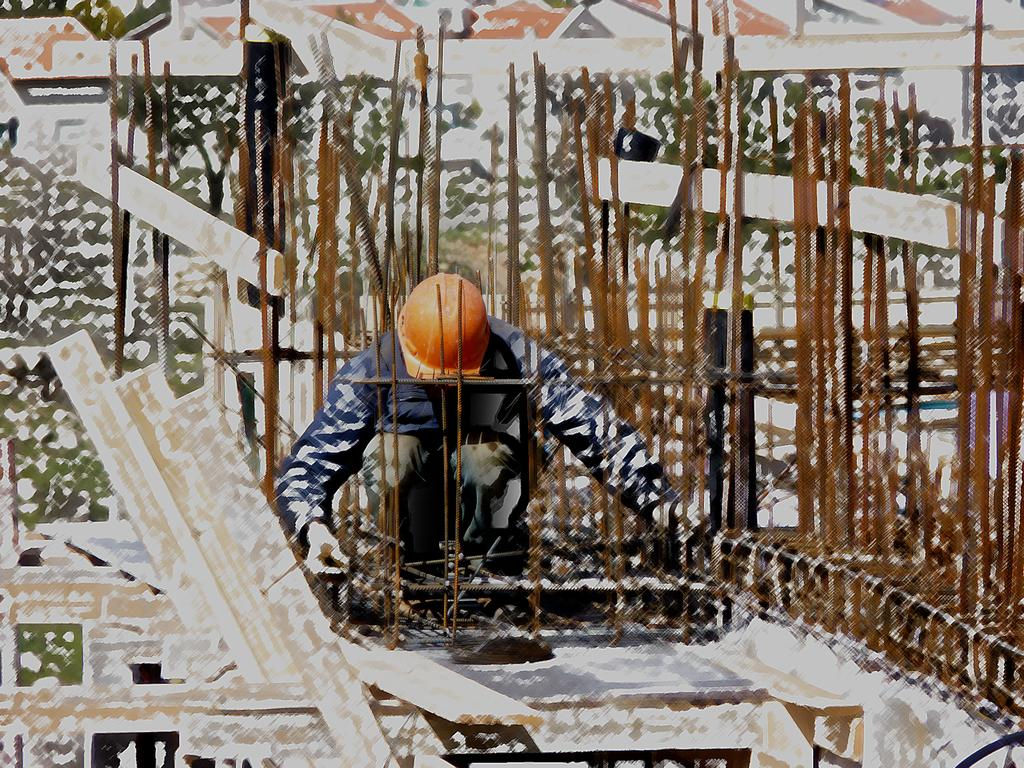What can be said about the nature of the image? The image is edited. Who or what is the main subject in the image? There is a man in the middle of the image. What objects are present in the image? There are iron bars in the image. How would you describe the quality of the image? The image is a little blurred. How many toes can be seen on the man's feet in the image? There is no visible detail of the man's feet in the image, so it is impossible to determine the number of toes. What rule is being enforced by the man in the image? There is no indication of any rule or enforcement in the image; it simply features a man and iron bars. 